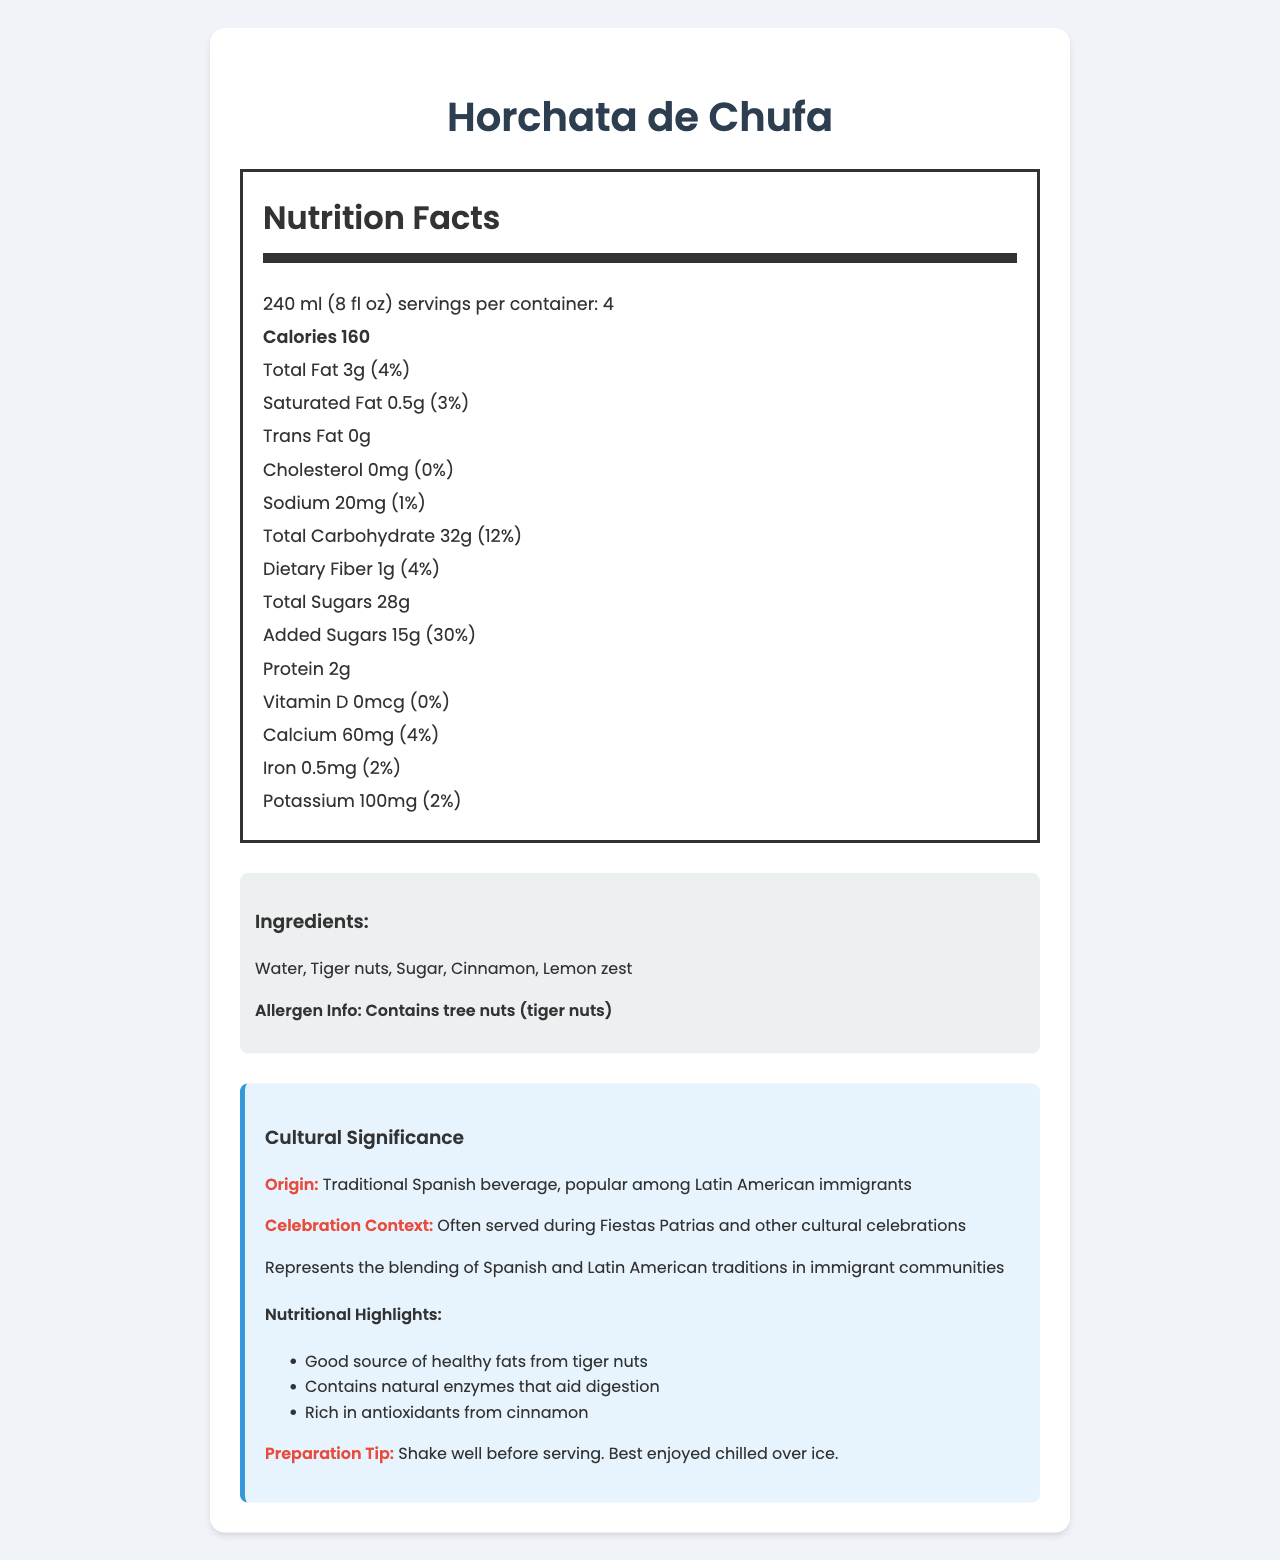what is the serving size for Horchata de Chufa? The serving size is stated in the document as "240 ml (8 fl oz)."
Answer: 240 ml (8 fl oz) how many calories are in one serving of Horchata de Chufa? The document mentions that there are 160 calories per serving.
Answer: 160 what is the total fat content in one serving? The total fat content per serving is listed as "3g."
Answer: 3g how much protein is there per serving? The document states that each serving contains 2g of protein.
Answer: 2g what is the percentage of daily value for added sugars? The daily value percentage for added sugars is given as "30%."
Answer: 30% how much calcium is there in one serving? A. 20mg B. 40mg C. 60mg D. 80mg The document states that there are 60mg of calcium per serving.
Answer: C how many servings are there per container? A. 2 B. 3 C. 4 D. 5 The document indicates that there are 4 servings per container.
Answer: C does this product contain cholesterol? The document specifies that there is "0mg" of cholesterol.
Answer: No is the beverage suitable for those with nut allergies? The allergen information states that the beverage contains tree nuts (tiger nuts), making it unsuitable for individuals with nut allergies.
Answer: No summarize the main nutritional content of Horchata de Chufa. This summary covers the primary nutritional components listed in the document, giving an overview of calories, fats, sugars, and micronutrients.
Answer: The beverage has 160 calories per serving, 3g total fat, 0.5g saturated fat, 0mg cholesterol, 20mg sodium, 32g total carbohydrates, 1g dietary fiber, 28g total sugars including 15g added sugars, and 2g protein. It offers some calcium, iron, and potassium. where is Horchata de Chufa traditionally consumed? The cultural information states that Horchata de Chufa is a traditional Spanish beverage popular among Latin American immigrants.
Answer: Spain and Latin America what antioxidants are found in this beverage? The document notes that the beverage is rich in antioxidants from cinnamon.
Answer: Cinnamon what preparation tip is provided? The preparation tip in the document advises shaking the beverage well before serving and recommends consuming it chilled over ice.
Answer: Shake well before serving. Best enjoyed chilled over ice. how many grams of added sugars are in this beverage? The added sugars are specifically listed as "15g" per serving.
Answer: 15g what makes Horchata de Chufa significant in immigrant celebrations? The document highlights that the beverage symbolizes the fusion of Spanish and Latin American cultures.
Answer: Represents the blending of Spanish and Latin American traditions in immigrant communities. how much vitamin D is in Horchata de Chufa? The document states that there is no Vitamin D (0mcg) in the beverage.
Answer: 0mcg how much dietary fiber does the beverage contain? The dietary fiber content per serving is 1g according to the document.
Answer: 1g what is the context in which this beverage is often consumed? The document states that the beverage is frequently enjoyed during cultural celebrations like Fiestas Patrias.
Answer: Often served during Fiestas Patrias and other cultural celebrations. does Horchata de Chufa contain trans fat? The document specifies that there are 0g of trans fat.
Answer: No what are the main ingredients in Horchata de Chufa? The document lists these as the main ingredients of the beverage.
Answer: Water, Tiger nuts, Sugar, Cinnamon, Lemon zest how much protein is in one container of Horchata de Chufa? The total protein in one container is 2g per serving multiplied by 4 servings per container.
Answer: 8g 